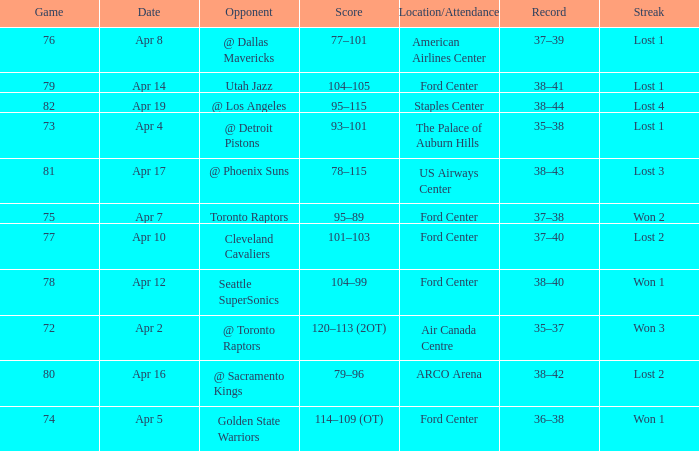What was the record for less than 78 games and a score of 114–109 (ot)? 36–38. 